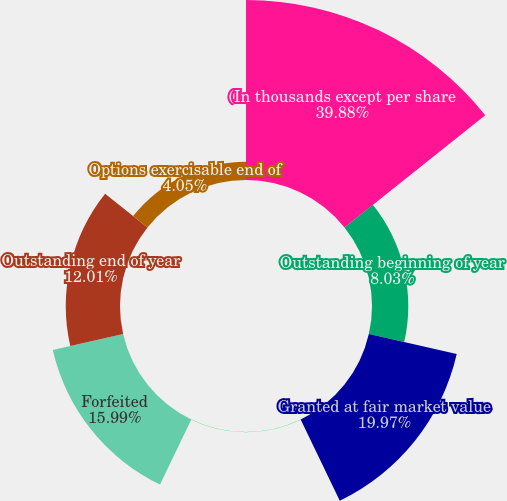<chart> <loc_0><loc_0><loc_500><loc_500><pie_chart><fcel>(In thousands except per share<fcel>Outstanding beginning of year<fcel>Granted at fair market value<fcel>Exercised<fcel>Forfeited<fcel>Outstanding end of year<fcel>Options exercisable end of<nl><fcel>39.88%<fcel>8.03%<fcel>19.97%<fcel>0.07%<fcel>15.99%<fcel>12.01%<fcel>4.05%<nl></chart> 